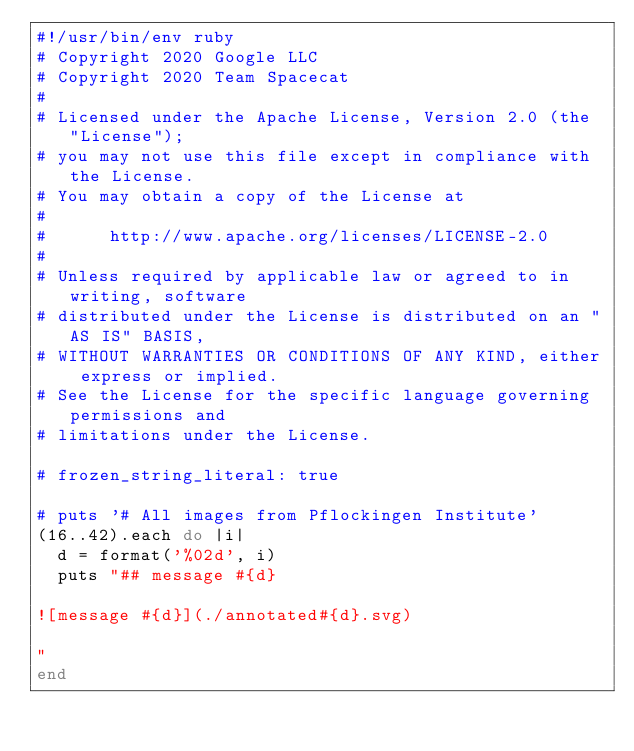<code> <loc_0><loc_0><loc_500><loc_500><_Ruby_>#!/usr/bin/env ruby
# Copyright 2020 Google LLC
# Copyright 2020 Team Spacecat
#
# Licensed under the Apache License, Version 2.0 (the "License");
# you may not use this file except in compliance with the License.
# You may obtain a copy of the License at
#
#      http://www.apache.org/licenses/LICENSE-2.0
#
# Unless required by applicable law or agreed to in writing, software
# distributed under the License is distributed on an "AS IS" BASIS,
# WITHOUT WARRANTIES OR CONDITIONS OF ANY KIND, either express or implied.
# See the License for the specific language governing permissions and
# limitations under the License.

# frozen_string_literal: true

# puts '# All images from Pflockingen Institute'
(16..42).each do |i|
  d = format('%02d', i)
  puts "## message #{d}

![message #{d}](./annotated#{d}.svg)

"
end
</code> 